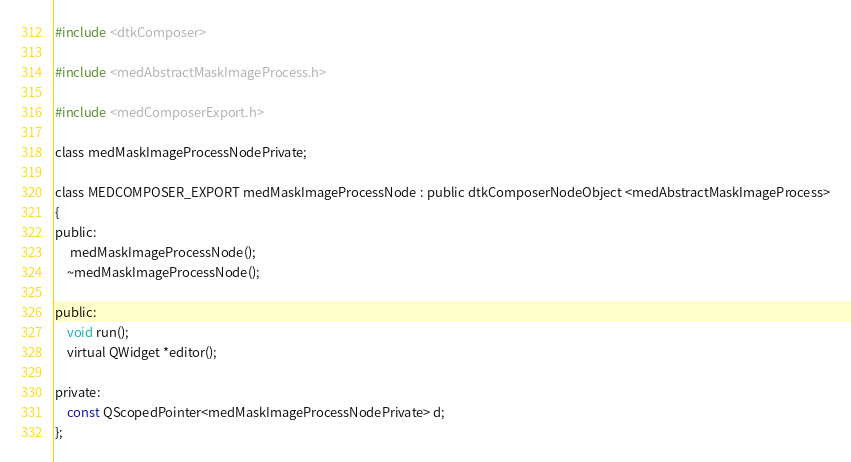Convert code to text. <code><loc_0><loc_0><loc_500><loc_500><_C_>
#include <dtkComposer>

#include <medAbstractMaskImageProcess.h>

#include <medComposerExport.h>

class medMaskImageProcessNodePrivate;

class MEDCOMPOSER_EXPORT medMaskImageProcessNode : public dtkComposerNodeObject <medAbstractMaskImageProcess>
{
public:
     medMaskImageProcessNode();
    ~medMaskImageProcessNode();

public:
    void run();
    virtual QWidget *editor();

private:
    const QScopedPointer<medMaskImageProcessNodePrivate> d;
};
</code> 